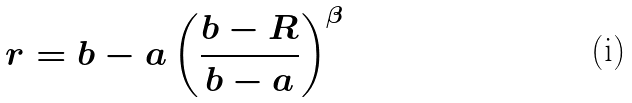Convert formula to latex. <formula><loc_0><loc_0><loc_500><loc_500>r = b - a \left ( \frac { b - R } { b - a } \right ) ^ { \beta }</formula> 